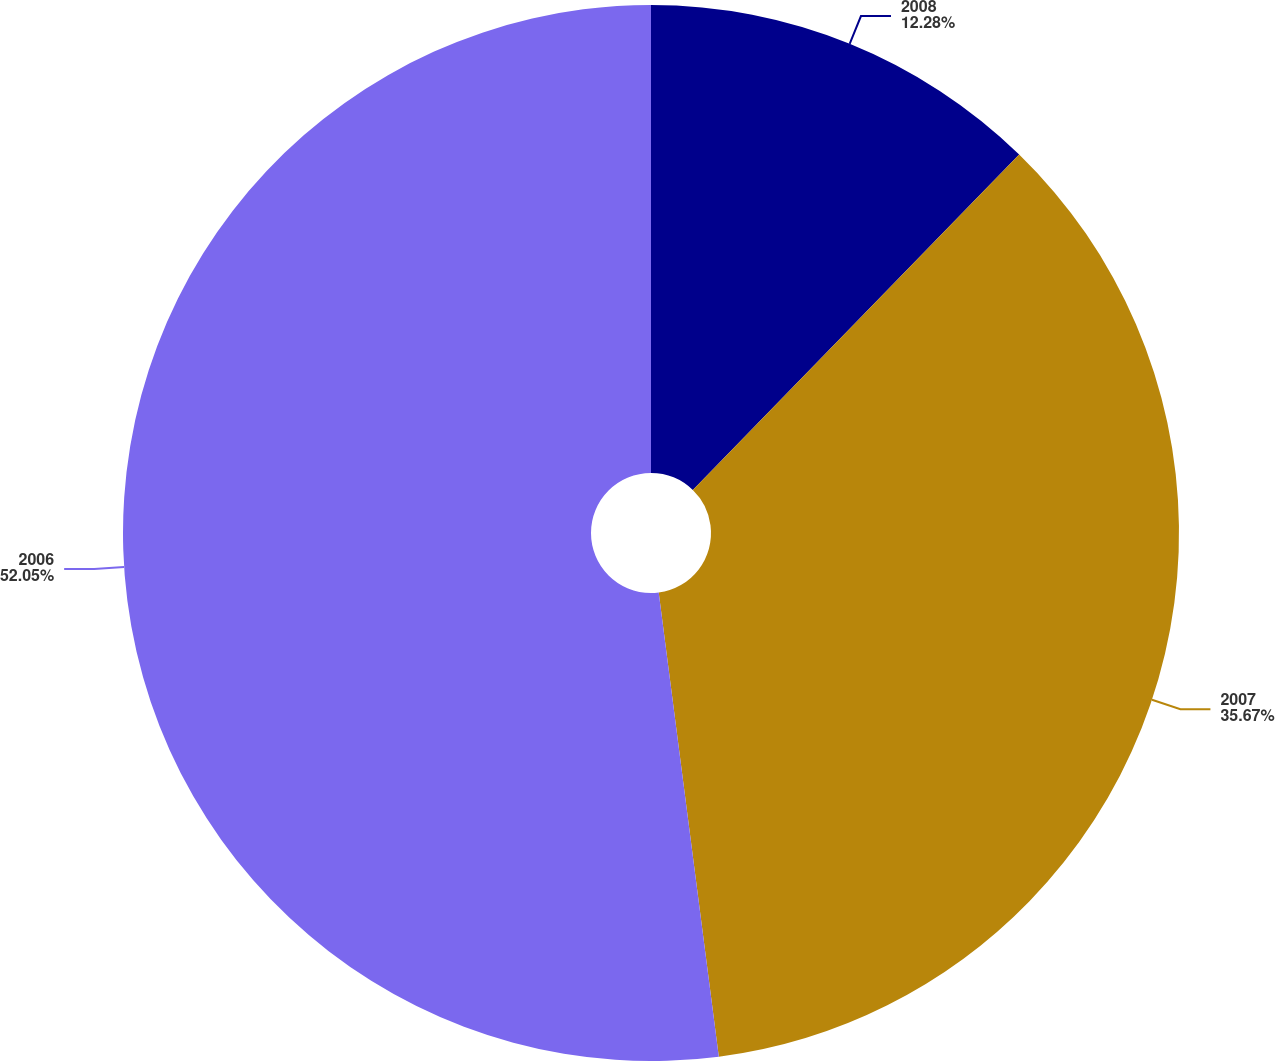Convert chart to OTSL. <chart><loc_0><loc_0><loc_500><loc_500><pie_chart><fcel>2008<fcel>2007<fcel>2006<nl><fcel>12.28%<fcel>35.67%<fcel>52.05%<nl></chart> 